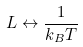<formula> <loc_0><loc_0><loc_500><loc_500>L \leftrightarrow \frac { 1 } { k _ { B } T } \,</formula> 